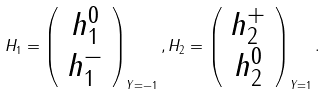Convert formula to latex. <formula><loc_0><loc_0><loc_500><loc_500>H _ { 1 } = \left ( \begin{array} { c } h ^ { 0 } _ { 1 } \\ h ^ { - } _ { 1 } \end{array} \right ) _ { Y = - 1 } , H _ { 2 } = \left ( \begin{array} { c } h ^ { + } _ { 2 } \\ h ^ { 0 } _ { 2 } \end{array} \right ) _ { Y = 1 } .</formula> 